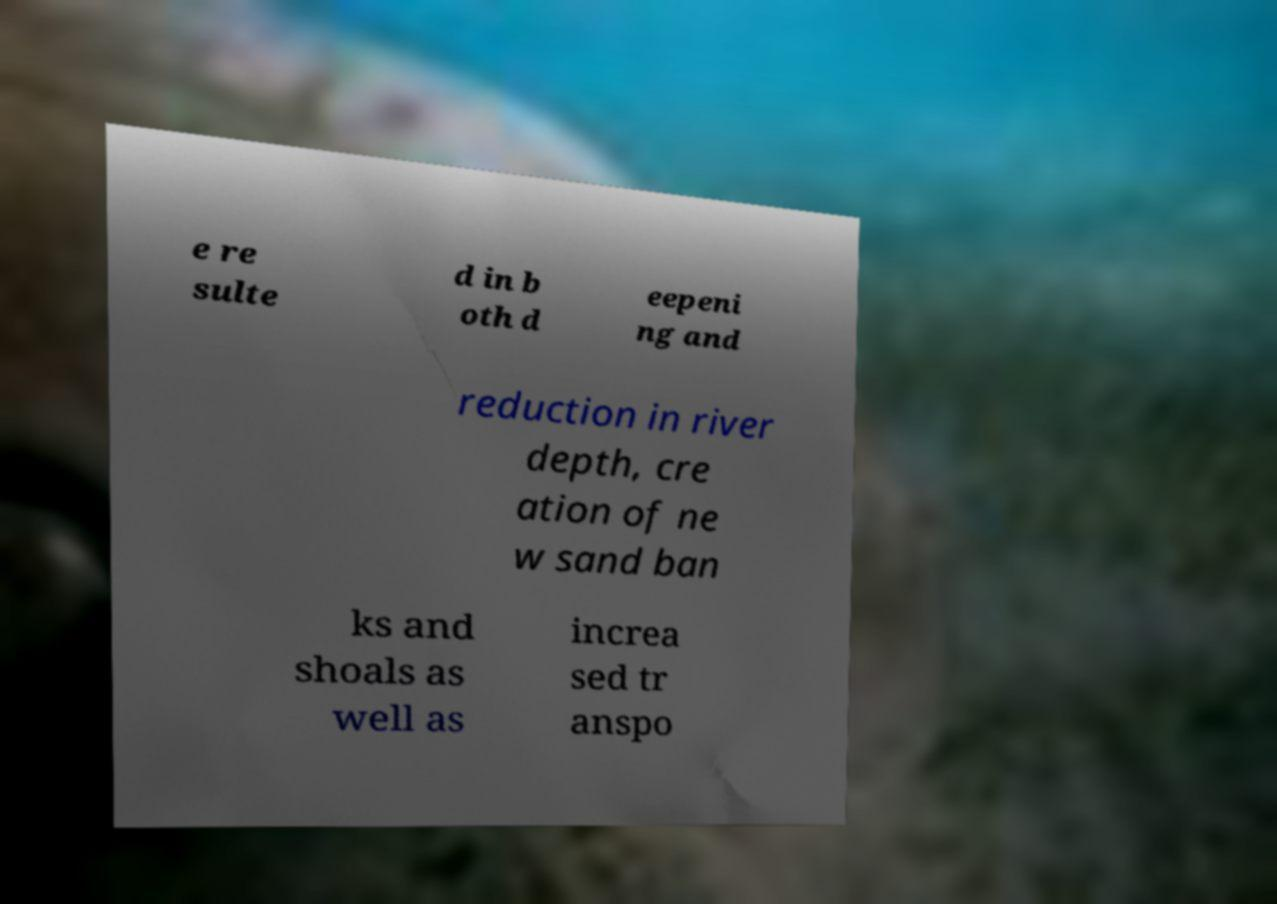I need the written content from this picture converted into text. Can you do that? e re sulte d in b oth d eepeni ng and reduction in river depth, cre ation of ne w sand ban ks and shoals as well as increa sed tr anspo 